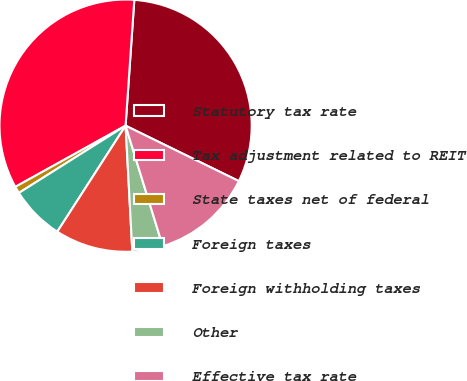Convert chart to OTSL. <chart><loc_0><loc_0><loc_500><loc_500><pie_chart><fcel>Statutory tax rate<fcel>Tax adjustment related to REIT<fcel>State taxes net of federal<fcel>Foreign taxes<fcel>Foreign withholding taxes<fcel>Other<fcel>Effective tax rate<nl><fcel>31.14%<fcel>34.16%<fcel>0.89%<fcel>6.94%<fcel>9.96%<fcel>3.91%<fcel>12.99%<nl></chart> 